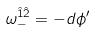<formula> <loc_0><loc_0><loc_500><loc_500>\omega _ { - } ^ { \hat { 1 } \hat { 2 } } = - d \phi ^ { \prime }</formula> 